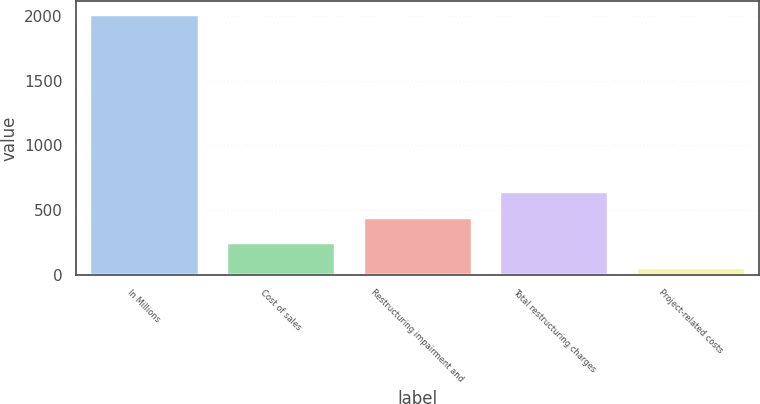<chart> <loc_0><loc_0><loc_500><loc_500><bar_chart><fcel>In Millions<fcel>Cost of sales<fcel>Restructuring impairment and<fcel>Total restructuring charges<fcel>Project-related costs<nl><fcel>2016<fcel>253.35<fcel>449.2<fcel>645.05<fcel>57.5<nl></chart> 